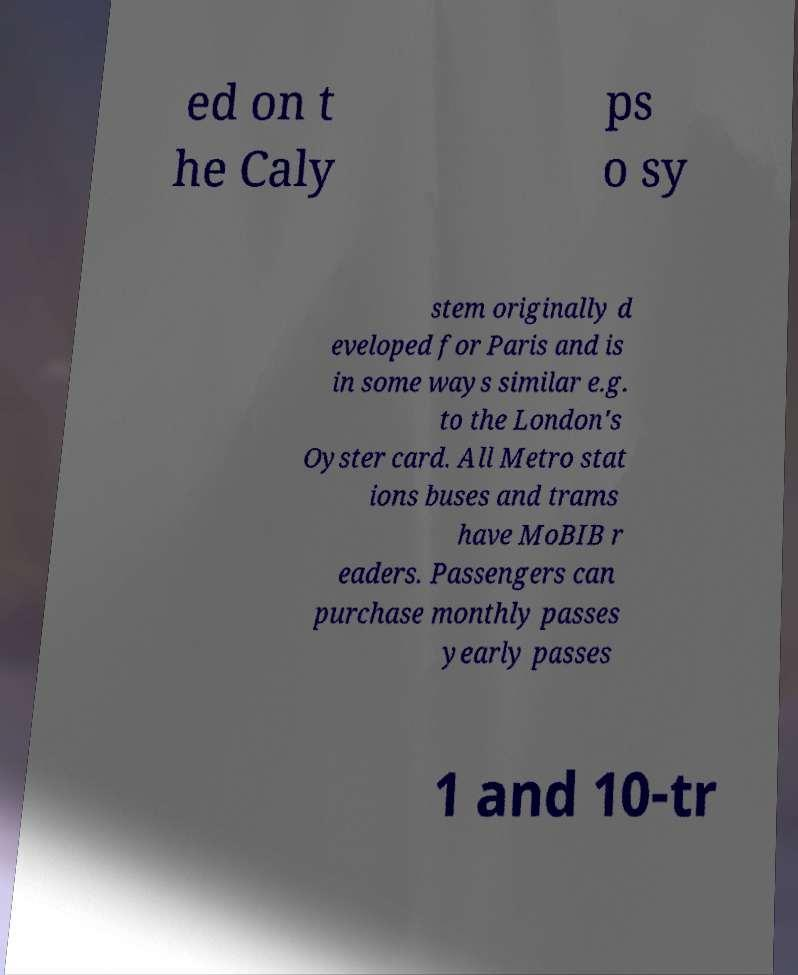Please read and relay the text visible in this image. What does it say? ed on t he Caly ps o sy stem originally d eveloped for Paris and is in some ways similar e.g. to the London's Oyster card. All Metro stat ions buses and trams have MoBIB r eaders. Passengers can purchase monthly passes yearly passes 1 and 10-tr 